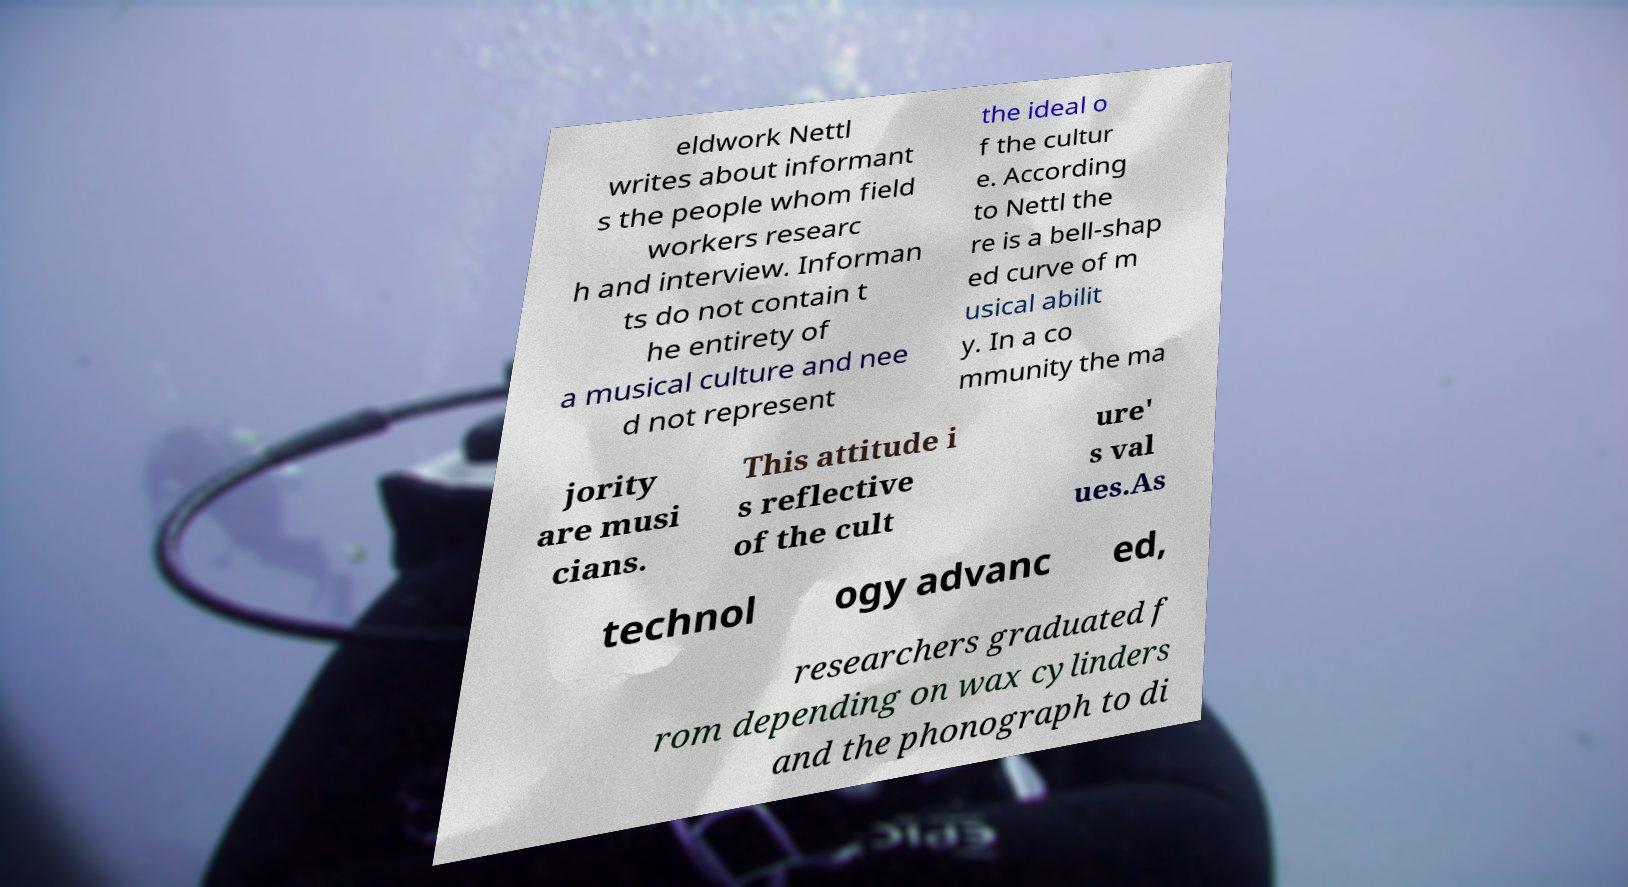For documentation purposes, I need the text within this image transcribed. Could you provide that? eldwork Nettl writes about informant s the people whom field workers researc h and interview. Informan ts do not contain t he entirety of a musical culture and nee d not represent the ideal o f the cultur e. According to Nettl the re is a bell-shap ed curve of m usical abilit y. In a co mmunity the ma jority are musi cians. This attitude i s reflective of the cult ure' s val ues.As technol ogy advanc ed, researchers graduated f rom depending on wax cylinders and the phonograph to di 